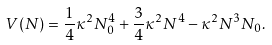<formula> <loc_0><loc_0><loc_500><loc_500>V ( N ) = \frac { 1 } { 4 } \kappa ^ { 2 } N _ { 0 } ^ { 4 } + \frac { 3 } { 4 } \kappa ^ { 2 } N ^ { 4 } - \kappa ^ { 2 } N ^ { 3 } N _ { 0 } .</formula> 